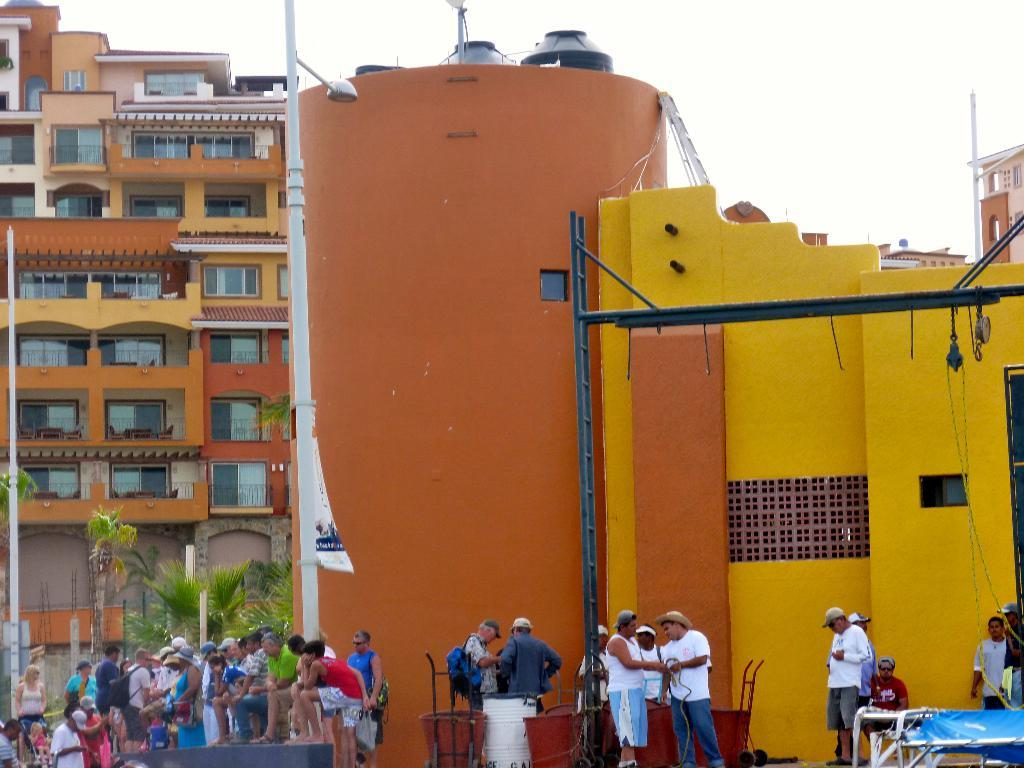How many people are in the image? There are persons in the image, but the exact number is not specified. What is the tall, vertical structure in the image? There is a light pole in the image. What type of structures can be seen in the image? There are buildings in the image. What is hanging or attached in the image? There is a banner in the image. What are the long, thin, and straight objects in the image? There are rods in the image. What can be seen through the openings in the buildings? There are windows in the image. What objects are present in the image? There are objects in the image, but their specific nature is not described. What type of containers are visible in the image? There are water tanks in the image. What is visible in the upper part of the image? The sky is visible in the image. What type of neck can be seen on the nation in the image? There is no nation or neck present in the image. What is the reason for the objects being in the image? The reason for the objects being in the image is not specified in the provided facts. 